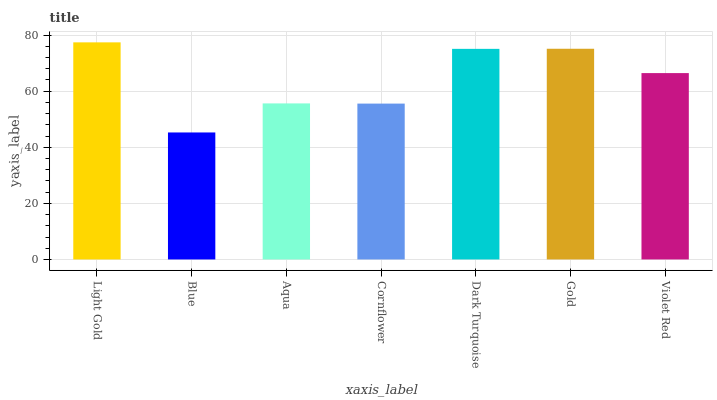Is Blue the minimum?
Answer yes or no. Yes. Is Light Gold the maximum?
Answer yes or no. Yes. Is Aqua the minimum?
Answer yes or no. No. Is Aqua the maximum?
Answer yes or no. No. Is Aqua greater than Blue?
Answer yes or no. Yes. Is Blue less than Aqua?
Answer yes or no. Yes. Is Blue greater than Aqua?
Answer yes or no. No. Is Aqua less than Blue?
Answer yes or no. No. Is Violet Red the high median?
Answer yes or no. Yes. Is Violet Red the low median?
Answer yes or no. Yes. Is Aqua the high median?
Answer yes or no. No. Is Gold the low median?
Answer yes or no. No. 